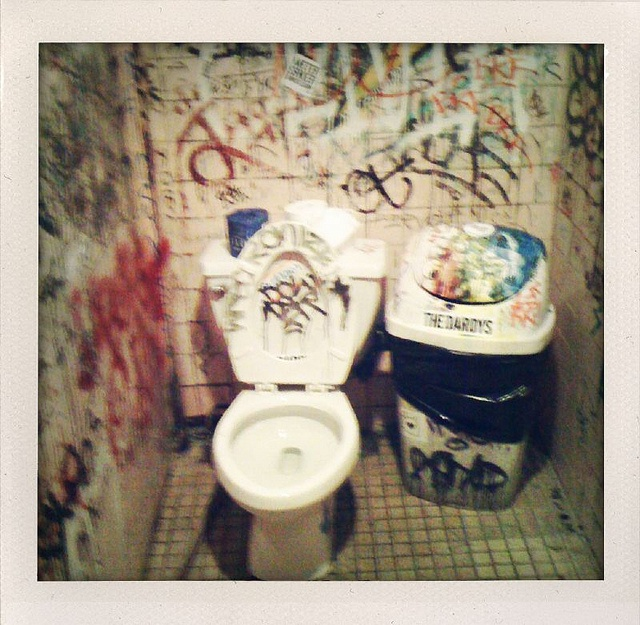Describe the objects in this image and their specific colors. I can see a toilet in lightgray, beige, and gray tones in this image. 